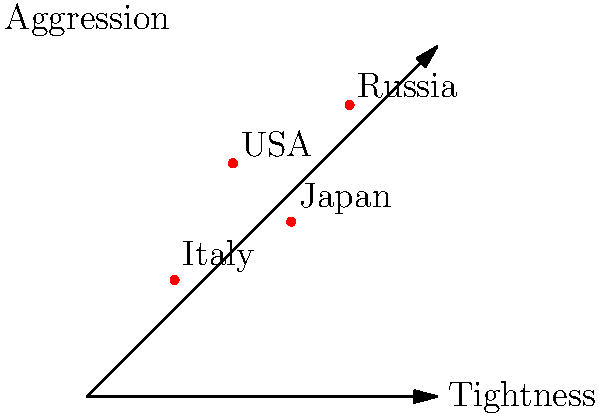Based on the graph comparing poker playing styles across different countries, which country's players exhibit the most aggressive and loose style? To answer this question, we need to analyze the graph and understand what the axes represent:

1. The x-axis represents "Tightness," with values increasing from left to right.
2. The y-axis represents "Aggression," with values increasing from bottom to top.

A loose and aggressive style would be represented by a point that is low on the tightness scale (closer to the left) and high on the aggression scale (closer to the top).

Examining the data points for each country:

1. Italy: Low tightness, low aggression
2. USA: Medium-low tightness, high aggression
3. Japan: Medium-high tightness, medium aggression
4. Russia: High tightness, very high aggression

Among these, the USA has the combination of relatively low tightness and high aggression, making it the most representative of a loose and aggressive playing style.
Answer: USA 